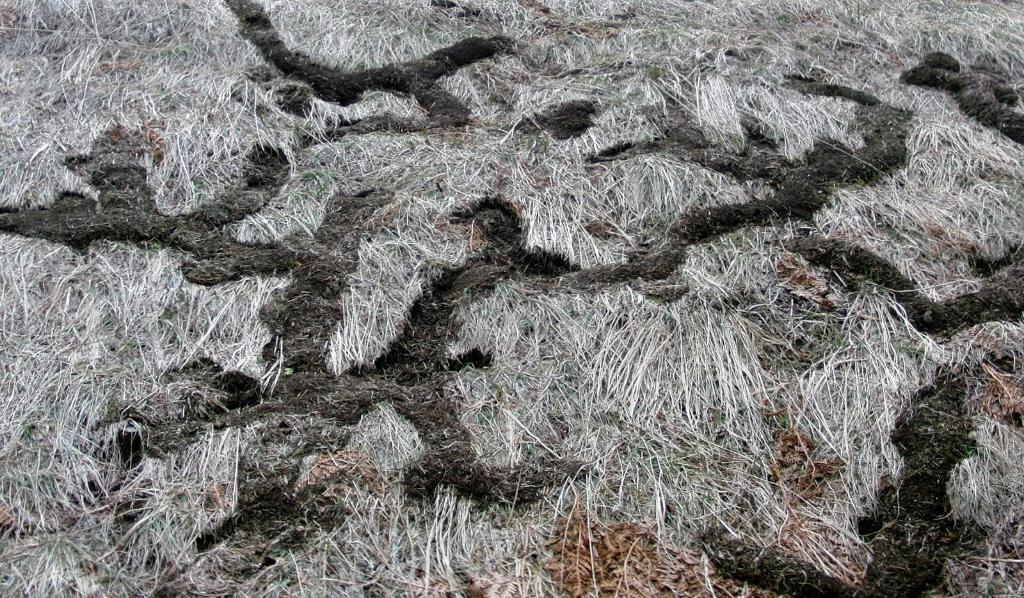Please provide a concise description of this image. In this image there is grass and dried leaves on the surface. 